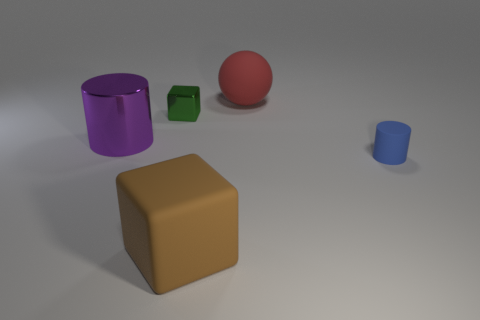Add 4 small blue spheres. How many objects exist? 9 Subtract all blocks. How many objects are left? 3 Add 1 matte spheres. How many matte spheres are left? 2 Add 3 large brown matte cylinders. How many large brown matte cylinders exist? 3 Subtract 0 green cylinders. How many objects are left? 5 Subtract all small gray rubber balls. Subtract all tiny blue rubber cylinders. How many objects are left? 4 